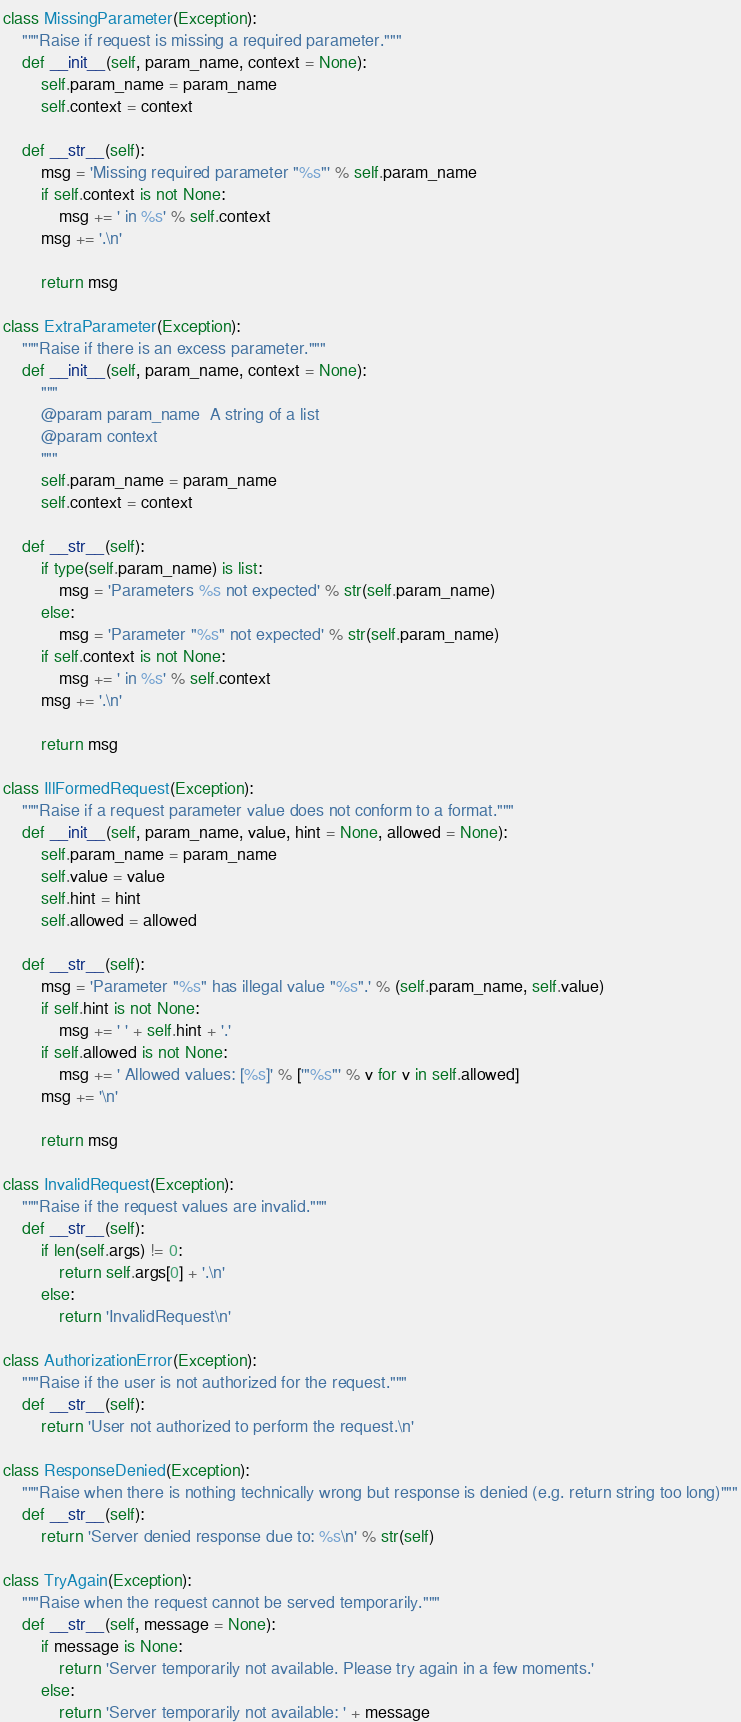<code> <loc_0><loc_0><loc_500><loc_500><_Python_>class MissingParameter(Exception):
    """Raise if request is missing a required parameter."""
    def __init__(self, param_name, context = None):
        self.param_name = param_name
        self.context = context

    def __str__(self):
        msg = 'Missing required parameter "%s"' % self.param_name
        if self.context is not None:
            msg += ' in %s' % self.context
        msg += '.\n'

        return msg

class ExtraParameter(Exception):
    """Raise if there is an excess parameter."""
    def __init__(self, param_name, context = None):
        """
        @param param_name  A string of a list
        @param context
        """
        self.param_name = param_name
        self.context = context

    def __str__(self):
        if type(self.param_name) is list:
            msg = 'Parameters %s not expected' % str(self.param_name)
        else:
            msg = 'Parameter "%s" not expected' % str(self.param_name)
        if self.context is not None:
            msg += ' in %s' % self.context
        msg += '.\n'

        return msg

class IllFormedRequest(Exception):
    """Raise if a request parameter value does not conform to a format."""
    def __init__(self, param_name, value, hint = None, allowed = None):
        self.param_name = param_name
        self.value = value
        self.hint = hint
        self.allowed = allowed

    def __str__(self):
        msg = 'Parameter "%s" has illegal value "%s".' % (self.param_name, self.value)
        if self.hint is not None:
            msg += ' ' + self.hint + '.'
        if self.allowed is not None:
            msg += ' Allowed values: [%s]' % ['"%s"' % v for v in self.allowed]
        msg += '\n'

        return msg

class InvalidRequest(Exception):
    """Raise if the request values are invalid."""
    def __str__(self):
        if len(self.args) != 0:
            return self.args[0] + '.\n'
        else:
            return 'InvalidRequest\n'

class AuthorizationError(Exception):
    """Raise if the user is not authorized for the request."""
    def __str__(self):
        return 'User not authorized to perform the request.\n'

class ResponseDenied(Exception):
    """Raise when there is nothing technically wrong but response is denied (e.g. return string too long)"""
    def __str__(self):
        return 'Server denied response due to: %s\n' % str(self)

class TryAgain(Exception):
    """Raise when the request cannot be served temporarily."""
    def __str__(self, message = None):
        if message is None:
            return 'Server temporarily not available. Please try again in a few moments.'
        else:
            return 'Server temporarily not available: ' + message
</code> 